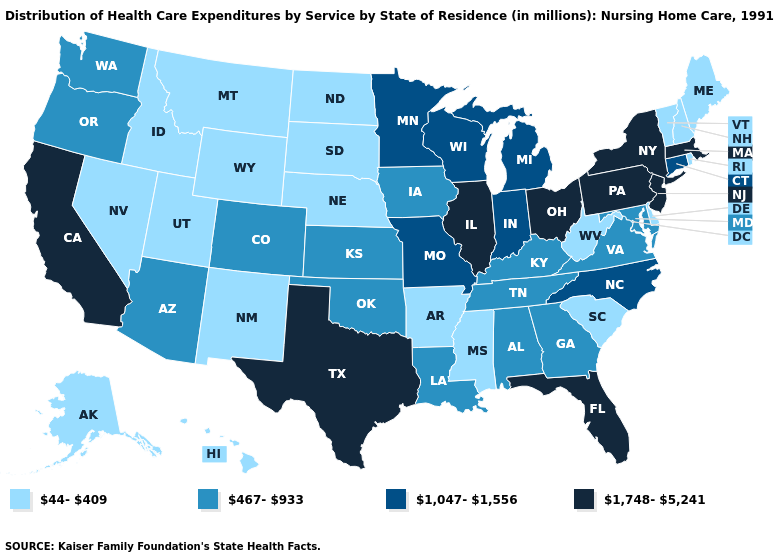Does Ohio have a lower value than Washington?
Concise answer only. No. How many symbols are there in the legend?
Short answer required. 4. What is the value of Kansas?
Short answer required. 467-933. What is the highest value in the South ?
Answer briefly. 1,748-5,241. Name the states that have a value in the range 1,748-5,241?
Be succinct. California, Florida, Illinois, Massachusetts, New Jersey, New York, Ohio, Pennsylvania, Texas. Among the states that border North Carolina , does Virginia have the lowest value?
Answer briefly. No. What is the highest value in the USA?
Give a very brief answer. 1,748-5,241. What is the value of Arizona?
Short answer required. 467-933. Name the states that have a value in the range 467-933?
Write a very short answer. Alabama, Arizona, Colorado, Georgia, Iowa, Kansas, Kentucky, Louisiana, Maryland, Oklahoma, Oregon, Tennessee, Virginia, Washington. What is the lowest value in the USA?
Keep it brief. 44-409. Does Colorado have a higher value than Hawaii?
Give a very brief answer. Yes. What is the highest value in states that border New Hampshire?
Be succinct. 1,748-5,241. Name the states that have a value in the range 1,748-5,241?
Answer briefly. California, Florida, Illinois, Massachusetts, New Jersey, New York, Ohio, Pennsylvania, Texas. Does North Dakota have the same value as West Virginia?
Concise answer only. Yes. Name the states that have a value in the range 467-933?
Answer briefly. Alabama, Arizona, Colorado, Georgia, Iowa, Kansas, Kentucky, Louisiana, Maryland, Oklahoma, Oregon, Tennessee, Virginia, Washington. 